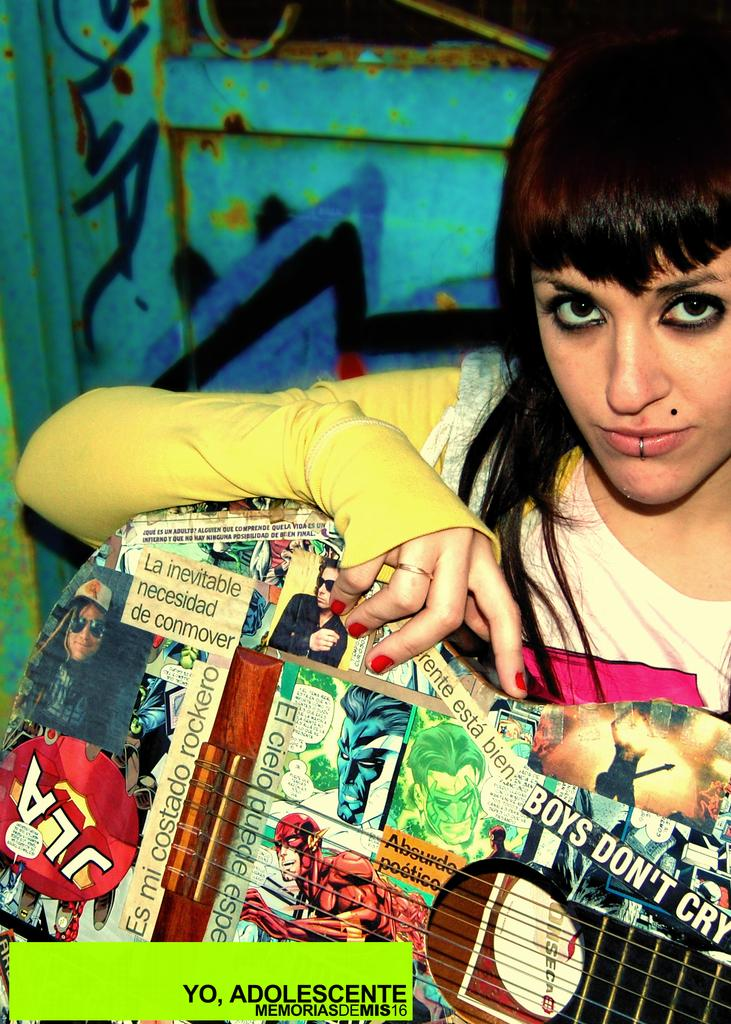Provide a one-sentence caption for the provided image. a girl holding a collection of comic books and boys dont cry bumper sticker. 